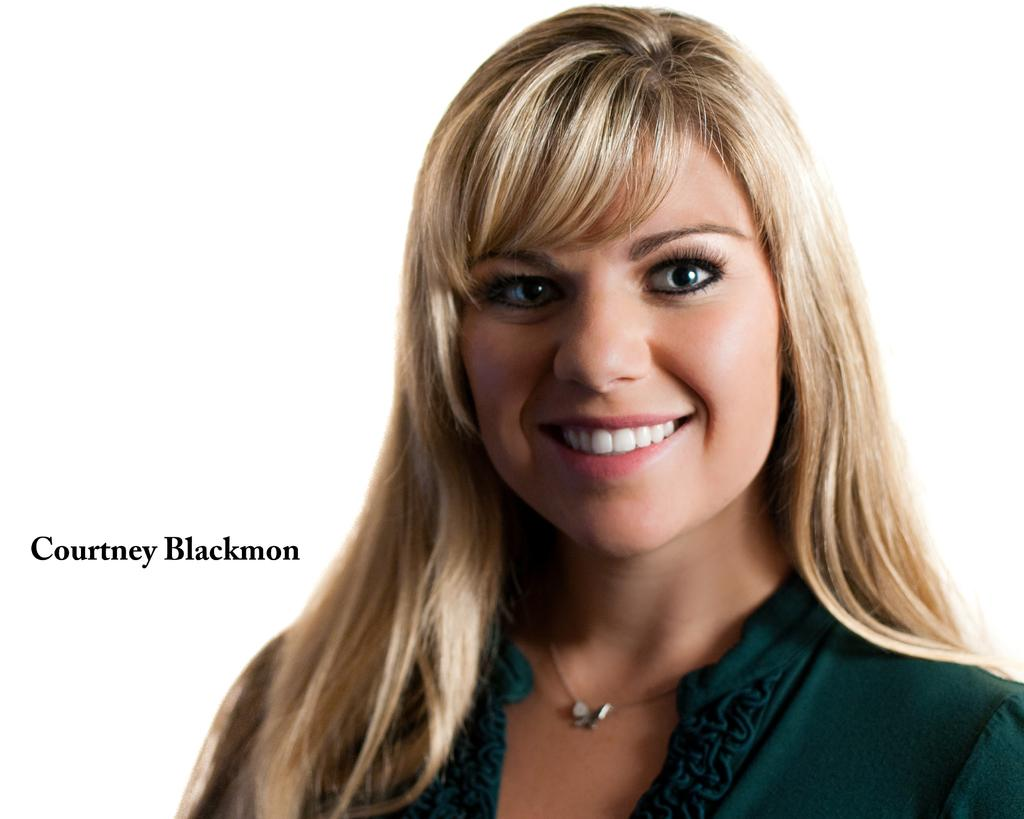Who is present in the image? There is a woman in the image. What is the woman's facial expression? The woman is smiling. What color is the background of the image? The background of the image appears to be white. How many trees can be seen in the image? There are no trees visible in the image. Is there a stranger interacting with the woman in the image? There is no stranger present in the image. 